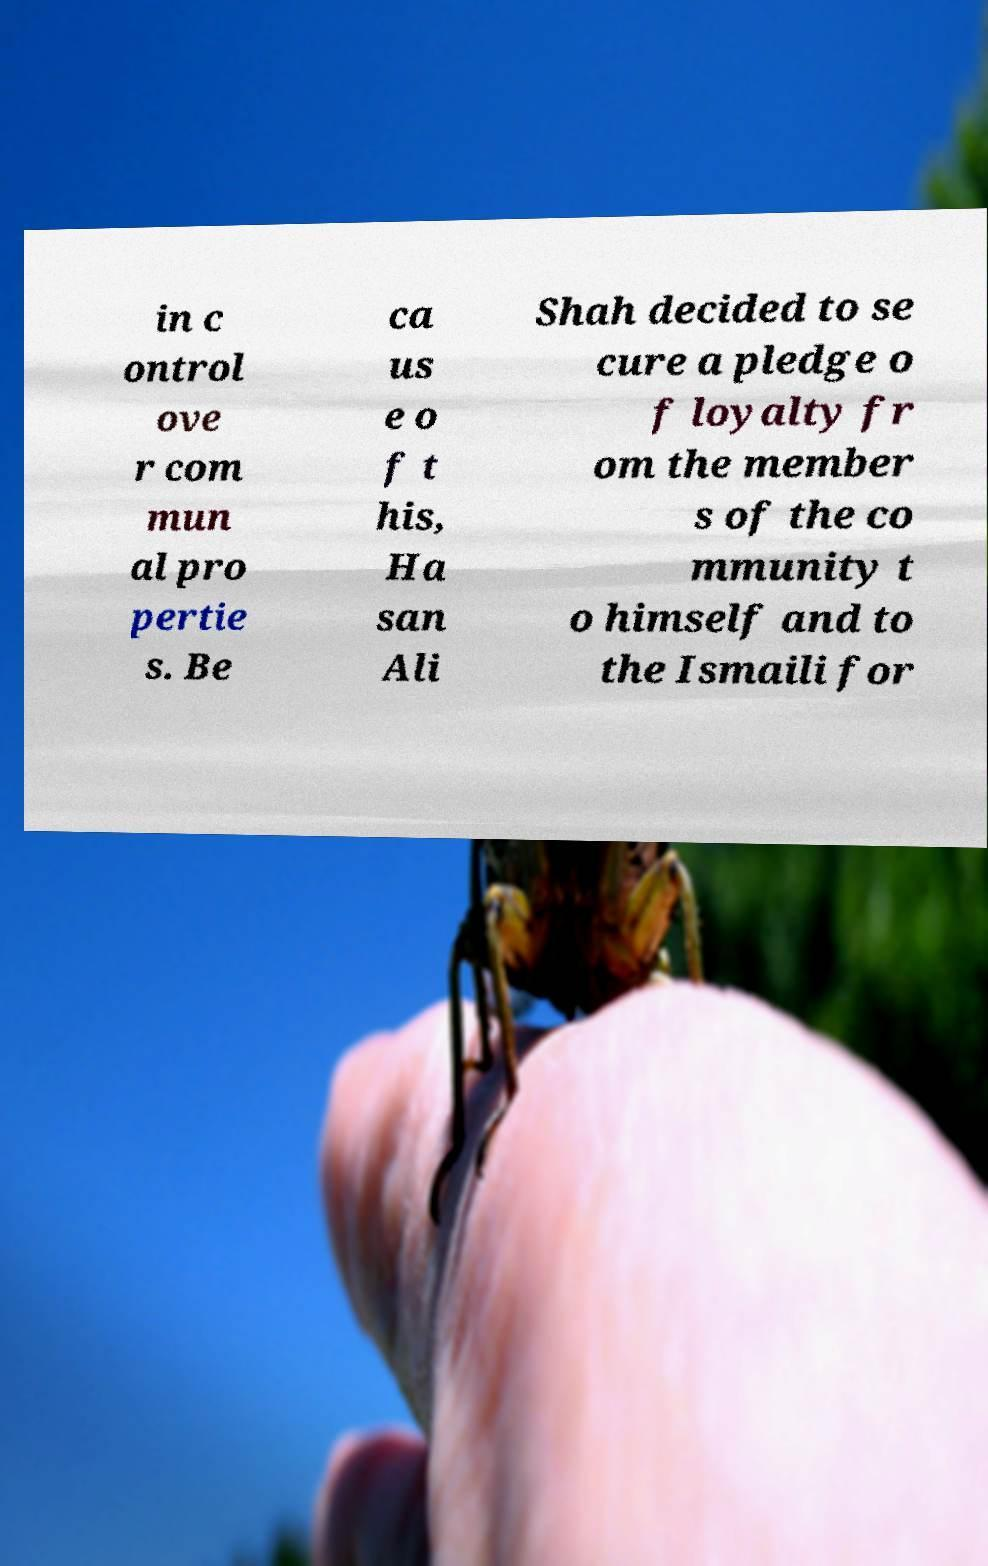I need the written content from this picture converted into text. Can you do that? in c ontrol ove r com mun al pro pertie s. Be ca us e o f t his, Ha san Ali Shah decided to se cure a pledge o f loyalty fr om the member s of the co mmunity t o himself and to the Ismaili for 